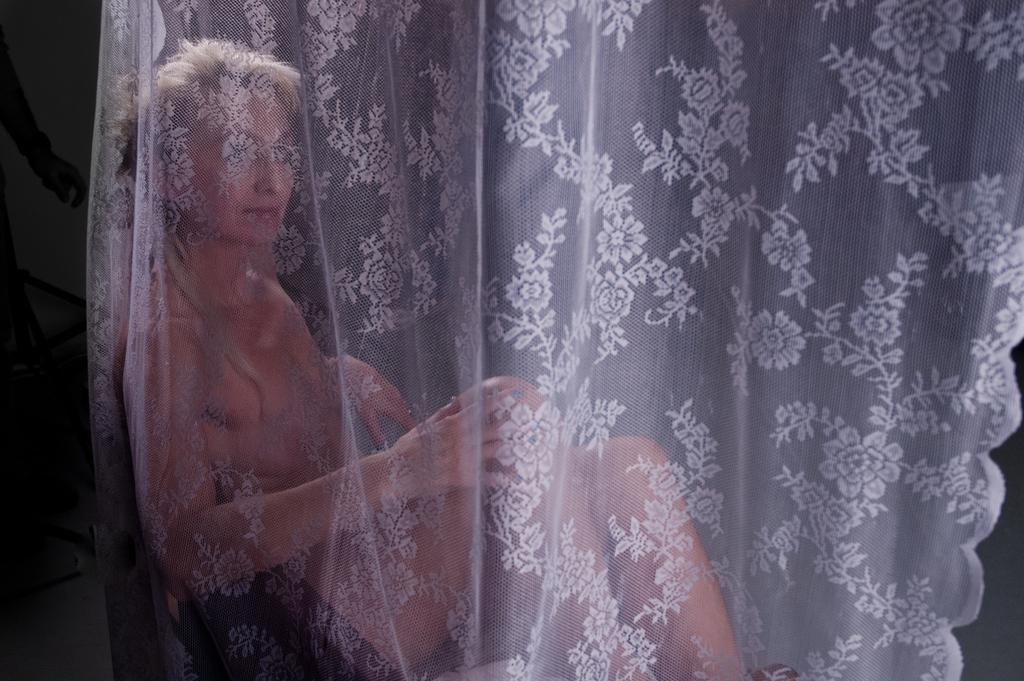What is present in the image that can be used to cover a window or door? There is a curtain in the image. What color is the curtain? The curtain is white in color. Is there any pattern or design on the curtain? Yes, there is a design on the curtain. Who is present behind the curtain in the image? There is a woman sitting behind the curtain. How would you describe the lighting in the image? The background of the image is slightly dark. What type of servant is attending to the woman behind the curtain in the image? There is no servant present in the image, and the woman is not being attended to by anyone. 